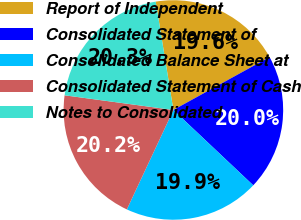Convert chart. <chart><loc_0><loc_0><loc_500><loc_500><pie_chart><fcel>Report of Independent<fcel>Consolidated Statement of<fcel>Consolidated Balance Sheet at<fcel>Consolidated Statement of Cash<fcel>Notes to Consolidated<nl><fcel>19.57%<fcel>20.05%<fcel>19.93%<fcel>20.17%<fcel>20.29%<nl></chart> 